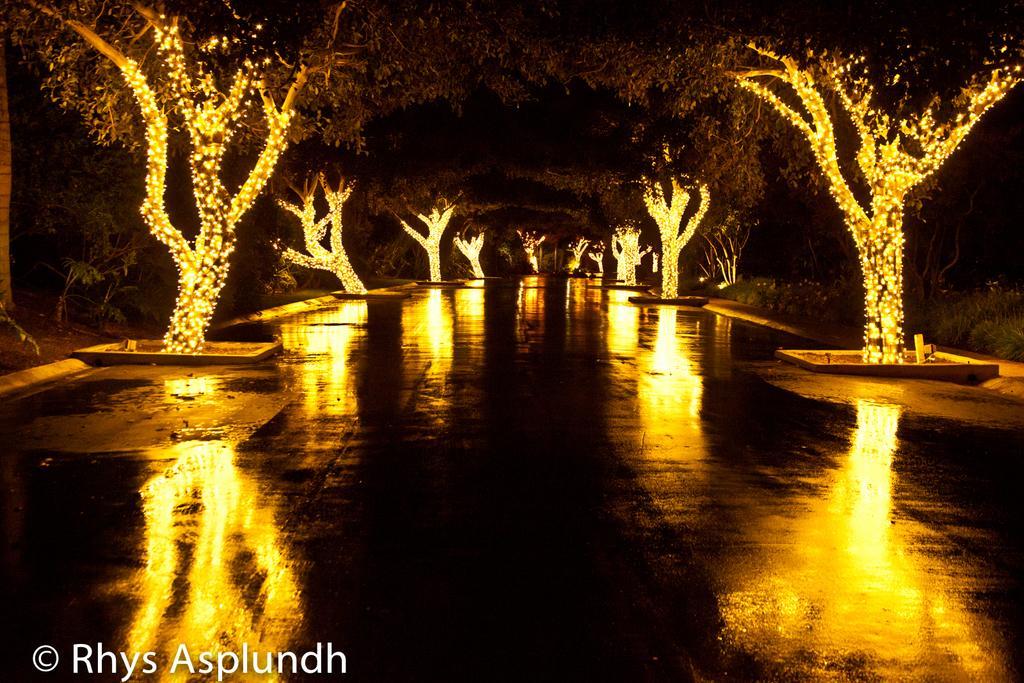Please provide a concise description of this image. In this picture we can see trees lighted up on either side of the road. 